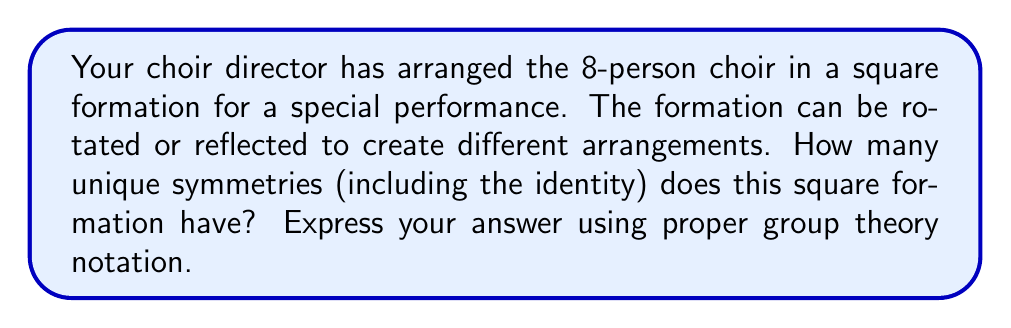Teach me how to tackle this problem. Let's approach this step-by-step:

1) First, we need to recognize that the symmetries of a square form the dihedral group $D_4$.

2) The symmetries of $D_4$ include:
   - The identity transformation (doing nothing)
   - Rotations: 90°, 180°, and 270° (3 rotations)
   - Reflections: 4 lines of symmetry (2 diagonals and 2 bisecting the sides)

3) To count these symmetries:
   - 1 identity transformation
   - 3 rotations
   - 4 reflections

4) In total, we have 1 + 3 + 4 = 8 symmetries

5) In group theory notation, we express this as:

   $$|D_4| = 8$$

   Where $|D_4|$ denotes the order (number of elements) of the dihedral group of order 4.

6) Alternatively, we can express this using the general formula for dihedral groups:

   $$|D_n| = 2n$$

   Where $n$ is the number of sides of the regular polygon (in this case, a square, so $n=4$).

   $$|D_4| = 2(4) = 8$$

Thus, the square formation of your 8-person choir has 8 unique symmetries.
Answer: $|D_4| = 8$ 